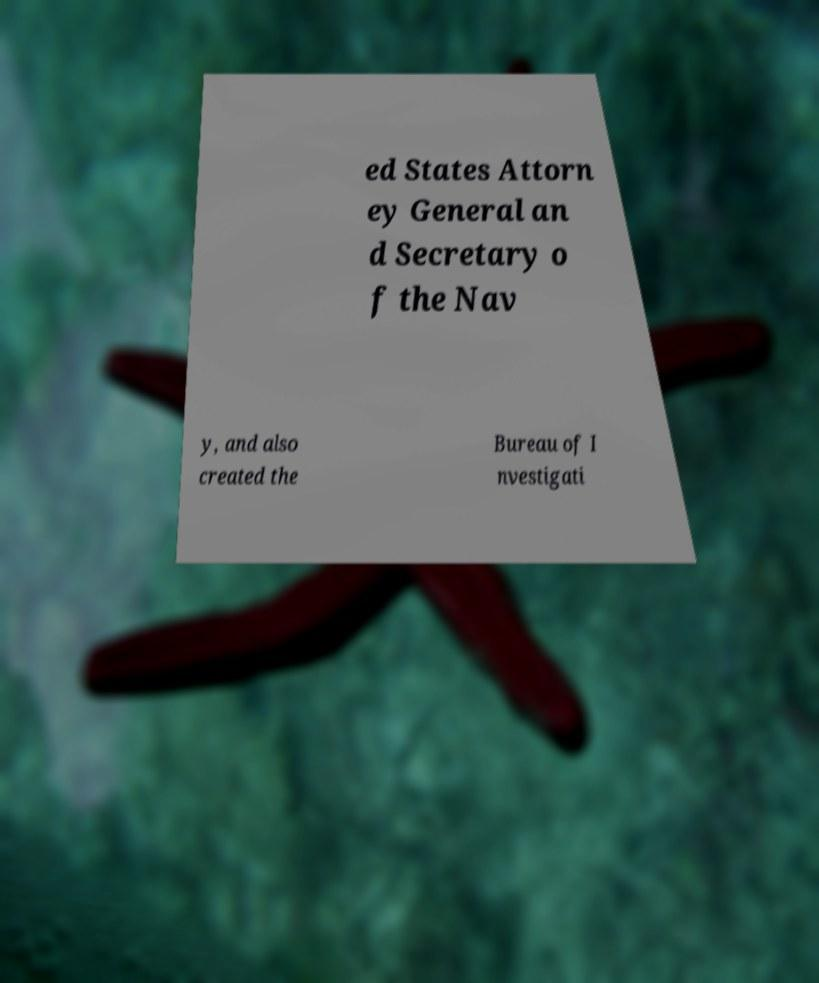For documentation purposes, I need the text within this image transcribed. Could you provide that? ed States Attorn ey General an d Secretary o f the Nav y, and also created the Bureau of I nvestigati 